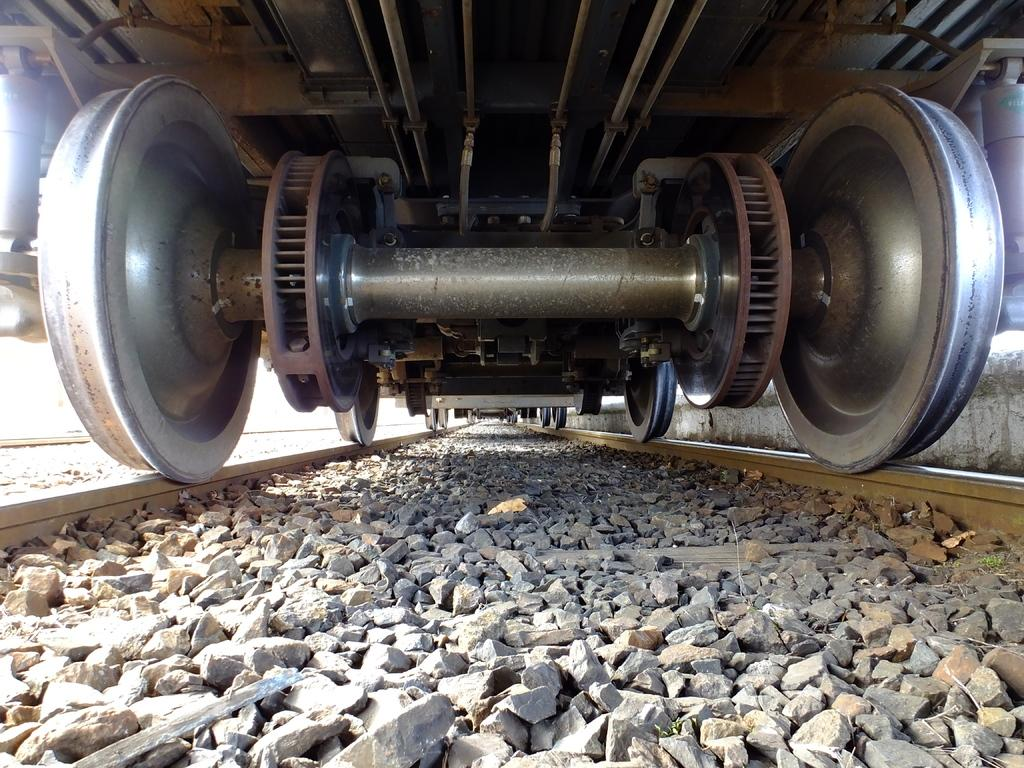What is the main subject of the image? The main subject of the image is a train. What is the train situated on? The train is on tracks. Are there any obstacles on the tracks in the image? Yes, there are stones in the middle of the tracks. What type of calendar is hanging on the wall near the train? There is no calendar present in the image; it only features a train on tracks with stones in the middle. 